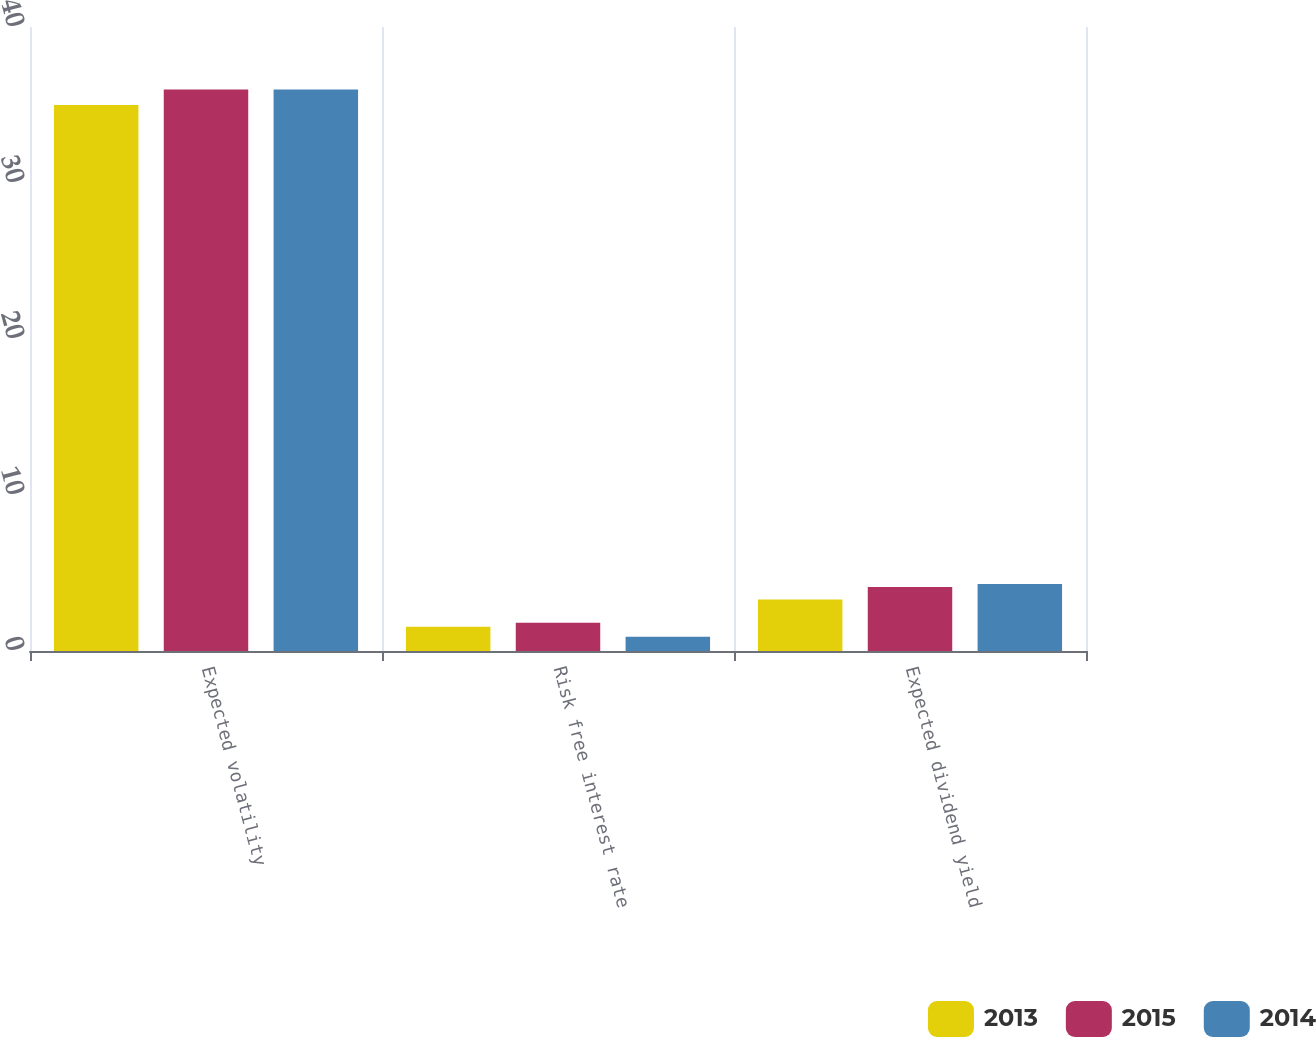<chart> <loc_0><loc_0><loc_500><loc_500><stacked_bar_chart><ecel><fcel>Expected volatility<fcel>Risk free interest rate<fcel>Expected dividend yield<nl><fcel>2013<fcel>35<fcel>1.56<fcel>3.3<nl><fcel>2015<fcel>36<fcel>1.81<fcel>4.1<nl><fcel>2014<fcel>36<fcel>0.91<fcel>4.3<nl></chart> 